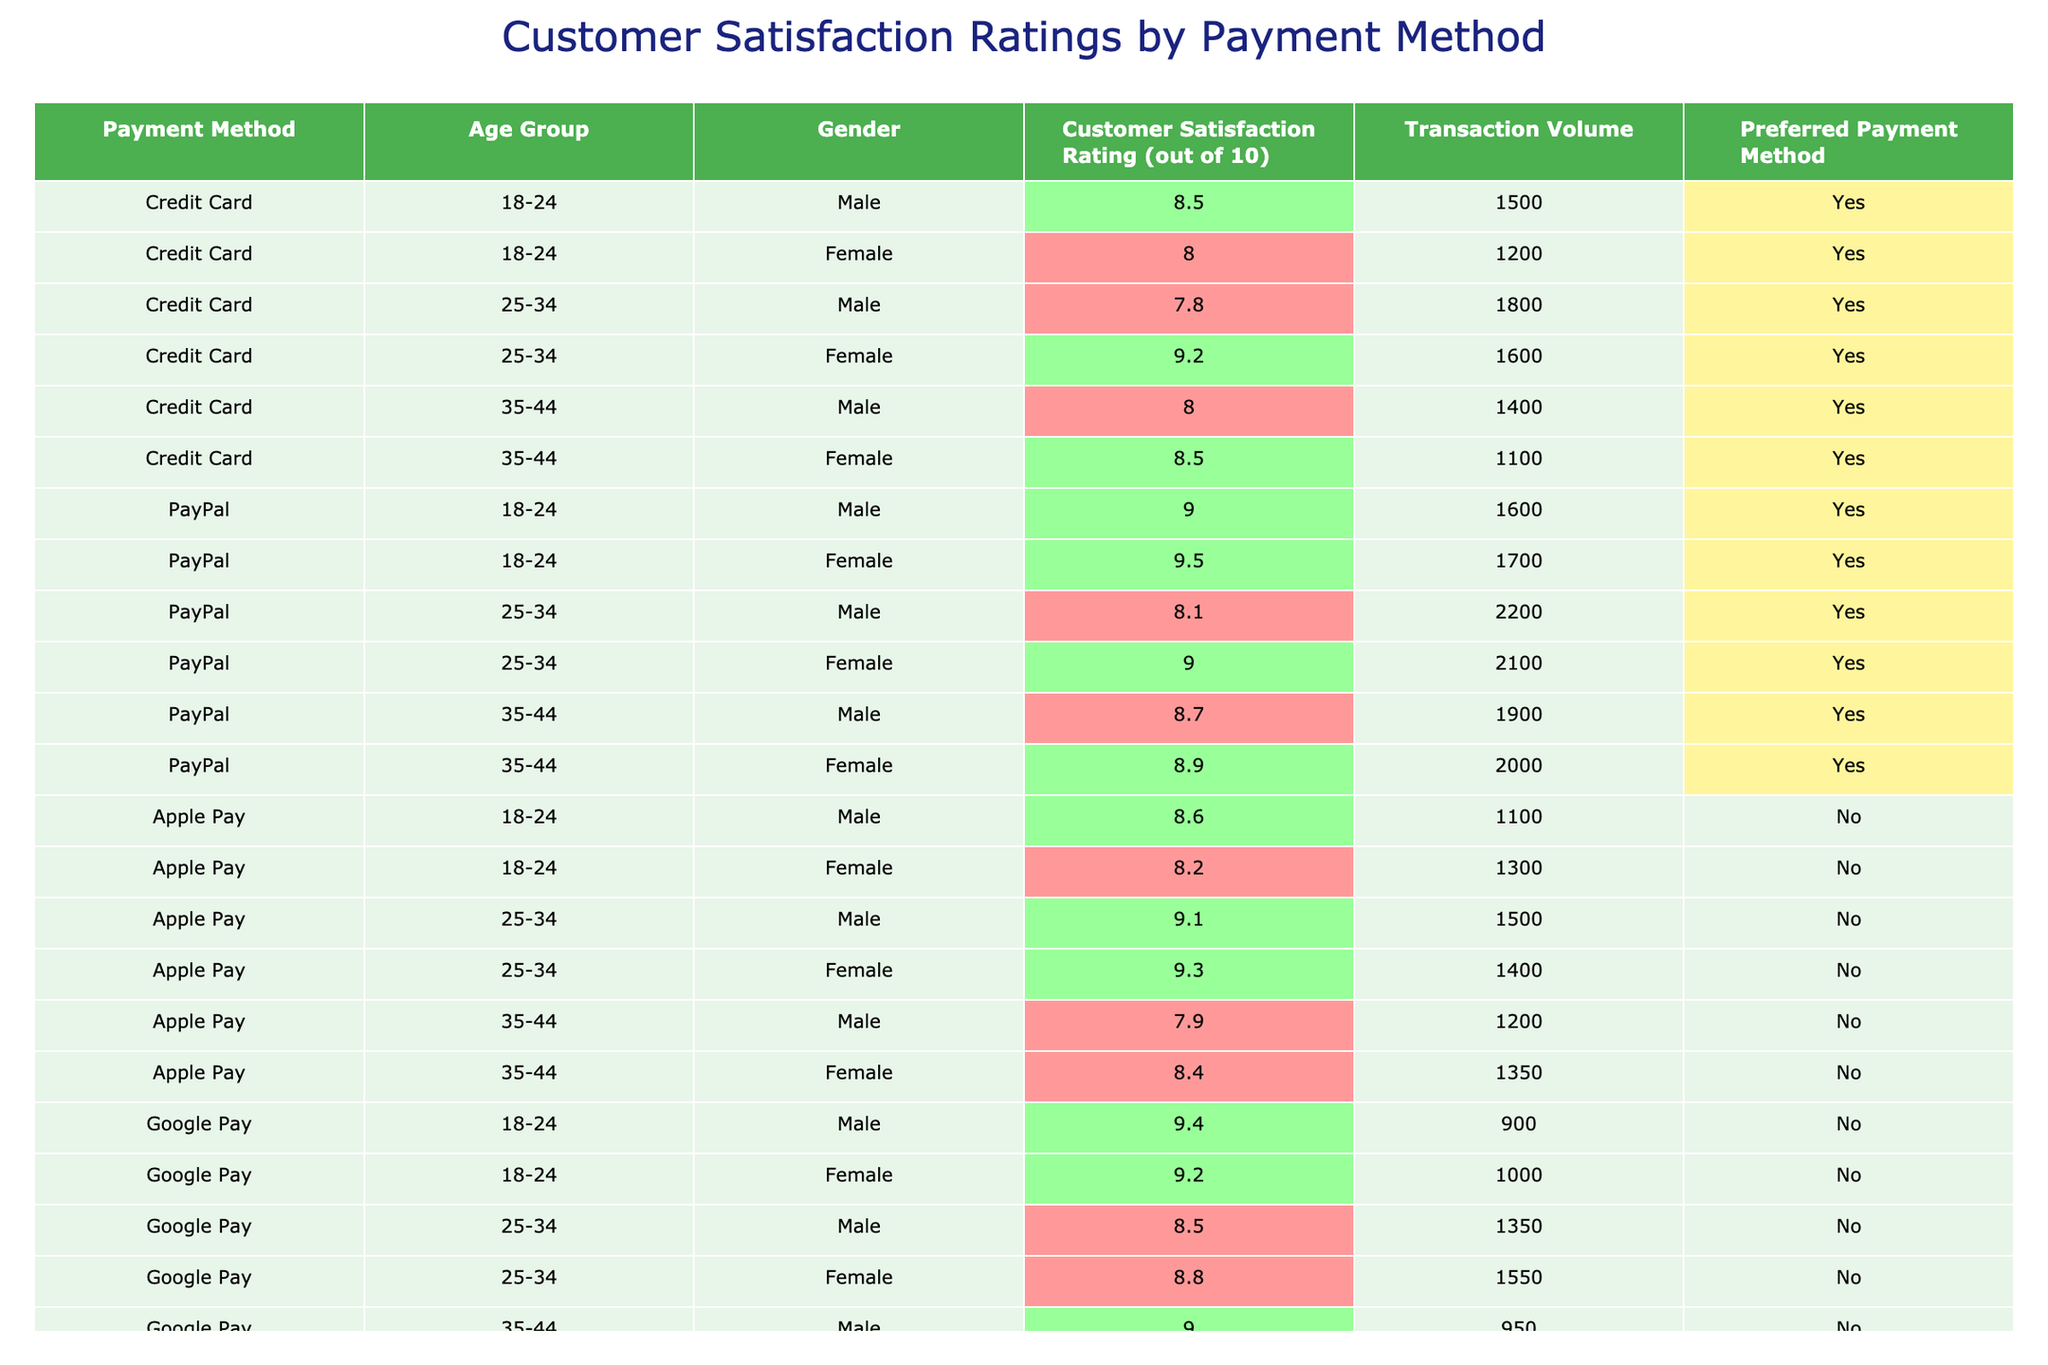What is the highest customer satisfaction rating? By reviewing the table, I can identify the highest customer satisfaction rating among all payment methods. After checking each rating, the highest value is 9.5, associated with PayPal for the 18-24 age group, female.
Answer: 9.5 Which payment method has the lowest satisfaction rating? I examined the ratings for all payment methods and found that Bank Transfer has the lowest average satisfaction rating of 7.0 for the 25-34 age group, male.
Answer: 7.0 What is the average customer satisfaction rating for PayPal users? I summed all the ratings for PayPal, which are 9.0, 9.5, 8.1, 9.0, 8.7, and 8.9. This totals to 52.2, and dividing by the number of entries (6) gives an average of 8.70.
Answer: 8.70 Do female customers prefer PayPal over Apple Pay? I compared the satisfaction ratings for females using PayPal (9.5, 9.0, 8.9) with those for Apple Pay (8.2, 9.3, 8.4). The average for PayPal is higher (9.13) compared to Apple Pay (8.67), indicating a preference for PayPal based on higher satisfaction ratings.
Answer: Yes How many transactions were recorded for the 35-44 age group using Credit Card? I added the transaction volumes for the 35-44 age group using Credit Card, which are 1400 (male) and 1100 (female). The total transaction volume is thus 2500.
Answer: 2500 Which age group has the highest average satisfaction rating across all payment methods? I calculated the average satisfaction ratings for each age group: 18-24 (8.72), 25-34 (8.57), and 35-44 (8.52). The highest average is for the 18-24 age group.
Answer: 18-24 Is there any payment method that has “Bank Transfer” rated above 8? I checked the "Bank Transfer" ratings and found they are all no higher than 7.8 across the demographics, confirming none exceed 8.
Answer: No What is the satisfaction rating difference between males and females in the 25-34 age group using Google Pay? For Google Pay in the 25-34 age group, male customers scored 8.5 while female customers scored 8.8. The difference in satisfaction ratings is calculated as 8.8 - 8.5 = 0.3.
Answer: 0.3 Which payment method has the highest transaction volume among the females aged 35-44? I reviewed the females in the 35-44 age group, finding that PayPal has the highest transaction volume of 2000, while both Apple Pay and Bank Transfer have lower volumes.
Answer: PayPal How many transactions were conducted using Credit Cards overall? I added the transaction volumes for all demographics using Credit Cards: 1500 + 1200 + 1800 + 1600 + 1400 + 1100, which totals 10200 transactions.
Answer: 10200 